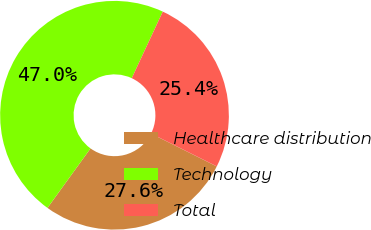Convert chart to OTSL. <chart><loc_0><loc_0><loc_500><loc_500><pie_chart><fcel>Healthcare distribution<fcel>Technology<fcel>Total<nl><fcel>27.59%<fcel>46.97%<fcel>25.44%<nl></chart> 